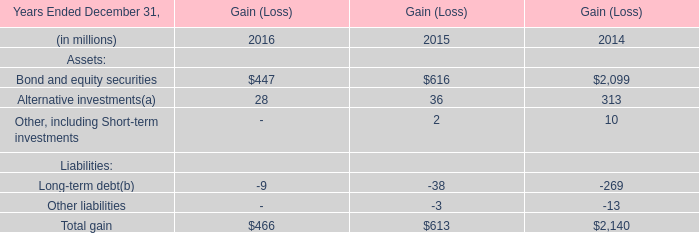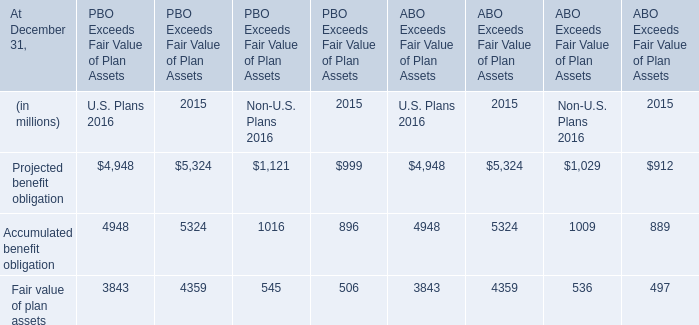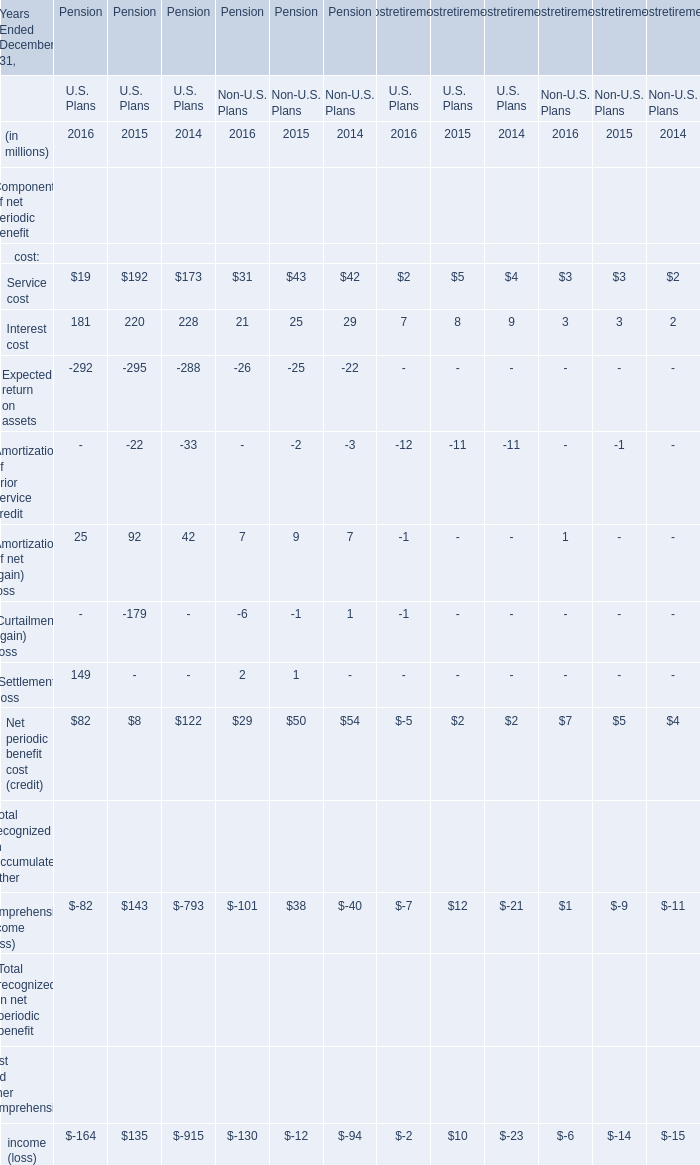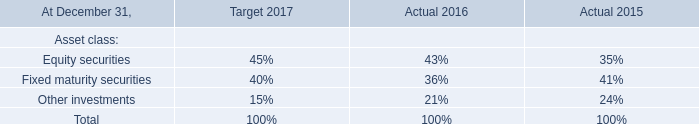what is the average price per share for the repurchased shares during 2005? 
Computations: (771 / 17)
Answer: 45.35294. 